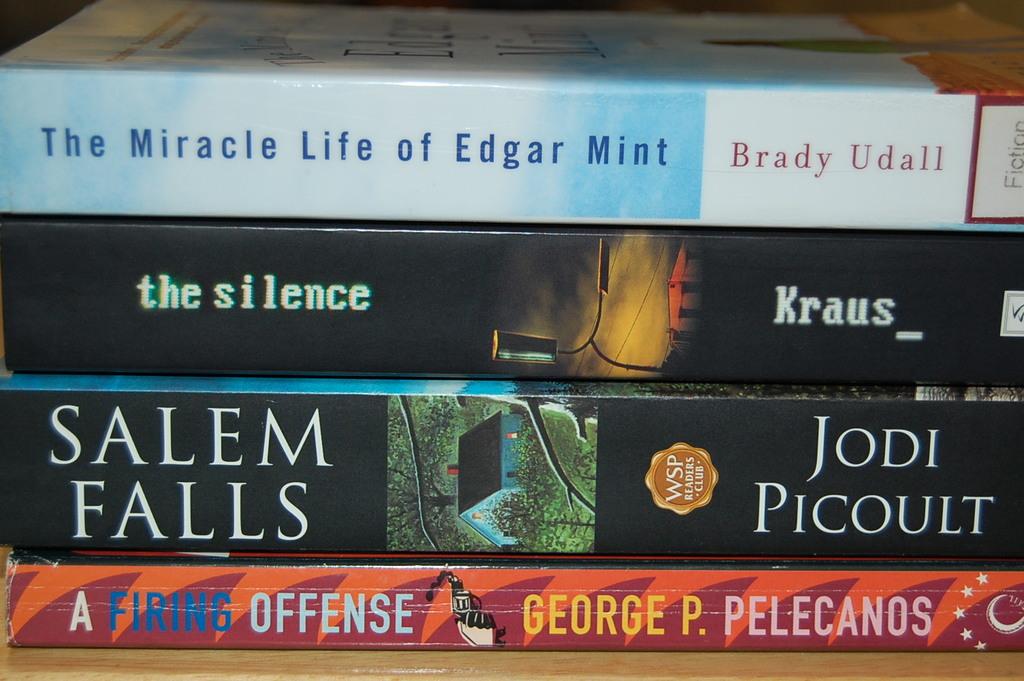Who wrote,"salem falls"?
Provide a short and direct response. Jodi picoult. Who wrote the silence?
Ensure brevity in your answer.  Kraus. 